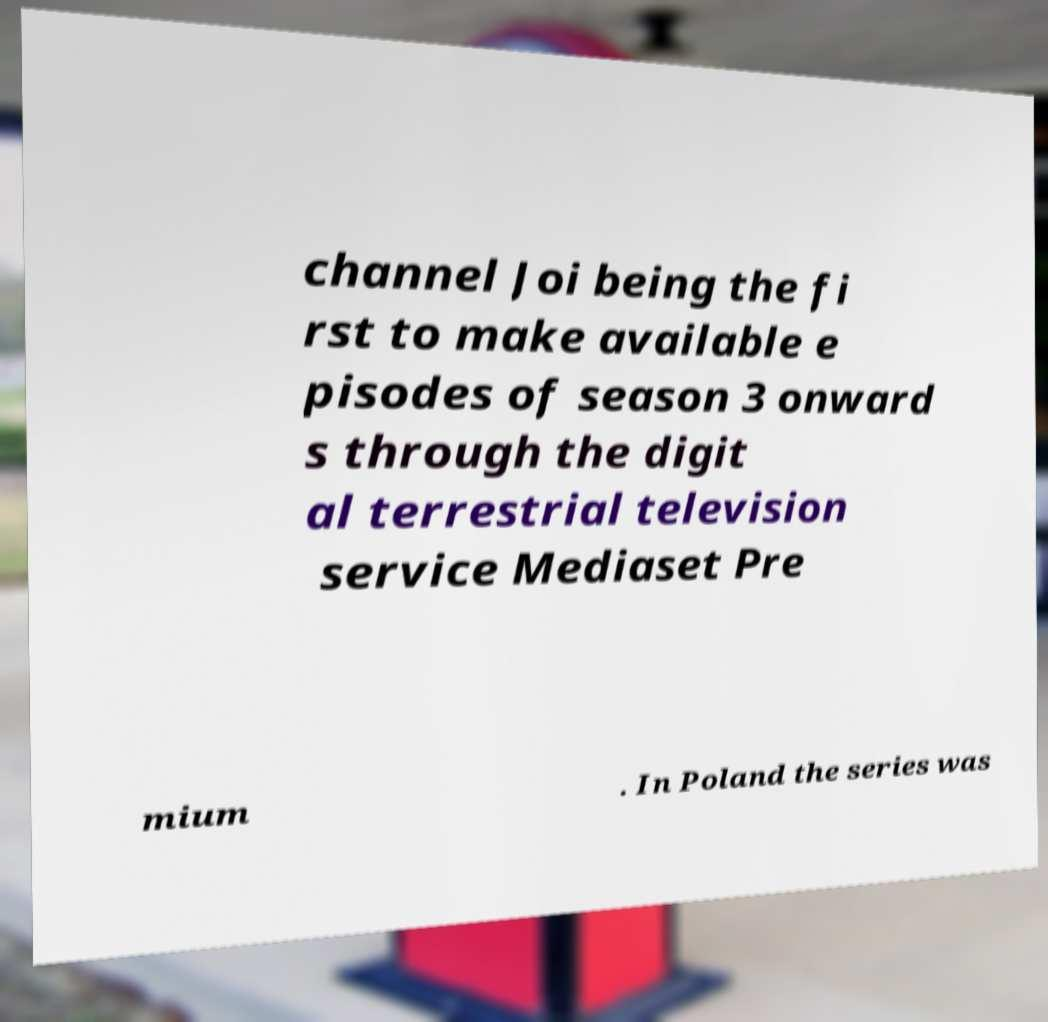I need the written content from this picture converted into text. Can you do that? channel Joi being the fi rst to make available e pisodes of season 3 onward s through the digit al terrestrial television service Mediaset Pre mium . In Poland the series was 